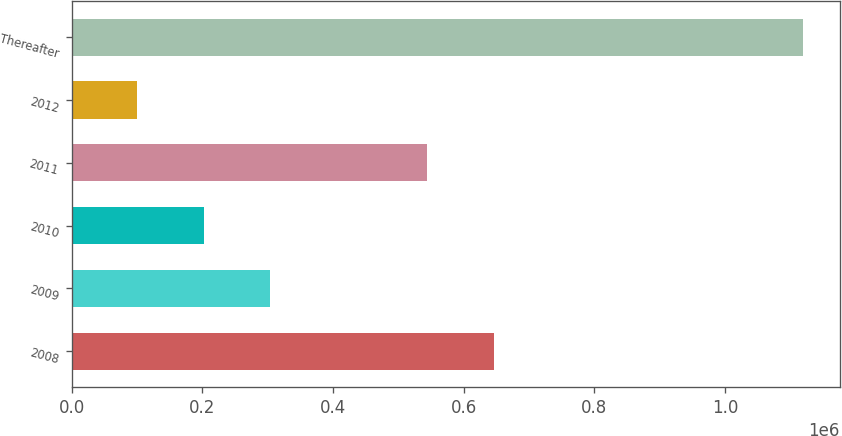<chart> <loc_0><loc_0><loc_500><loc_500><bar_chart><fcel>2008<fcel>2009<fcel>2010<fcel>2011<fcel>2012<fcel>Thereafter<nl><fcel>646621<fcel>304259<fcel>202326<fcel>544688<fcel>100393<fcel>1.11972e+06<nl></chart> 